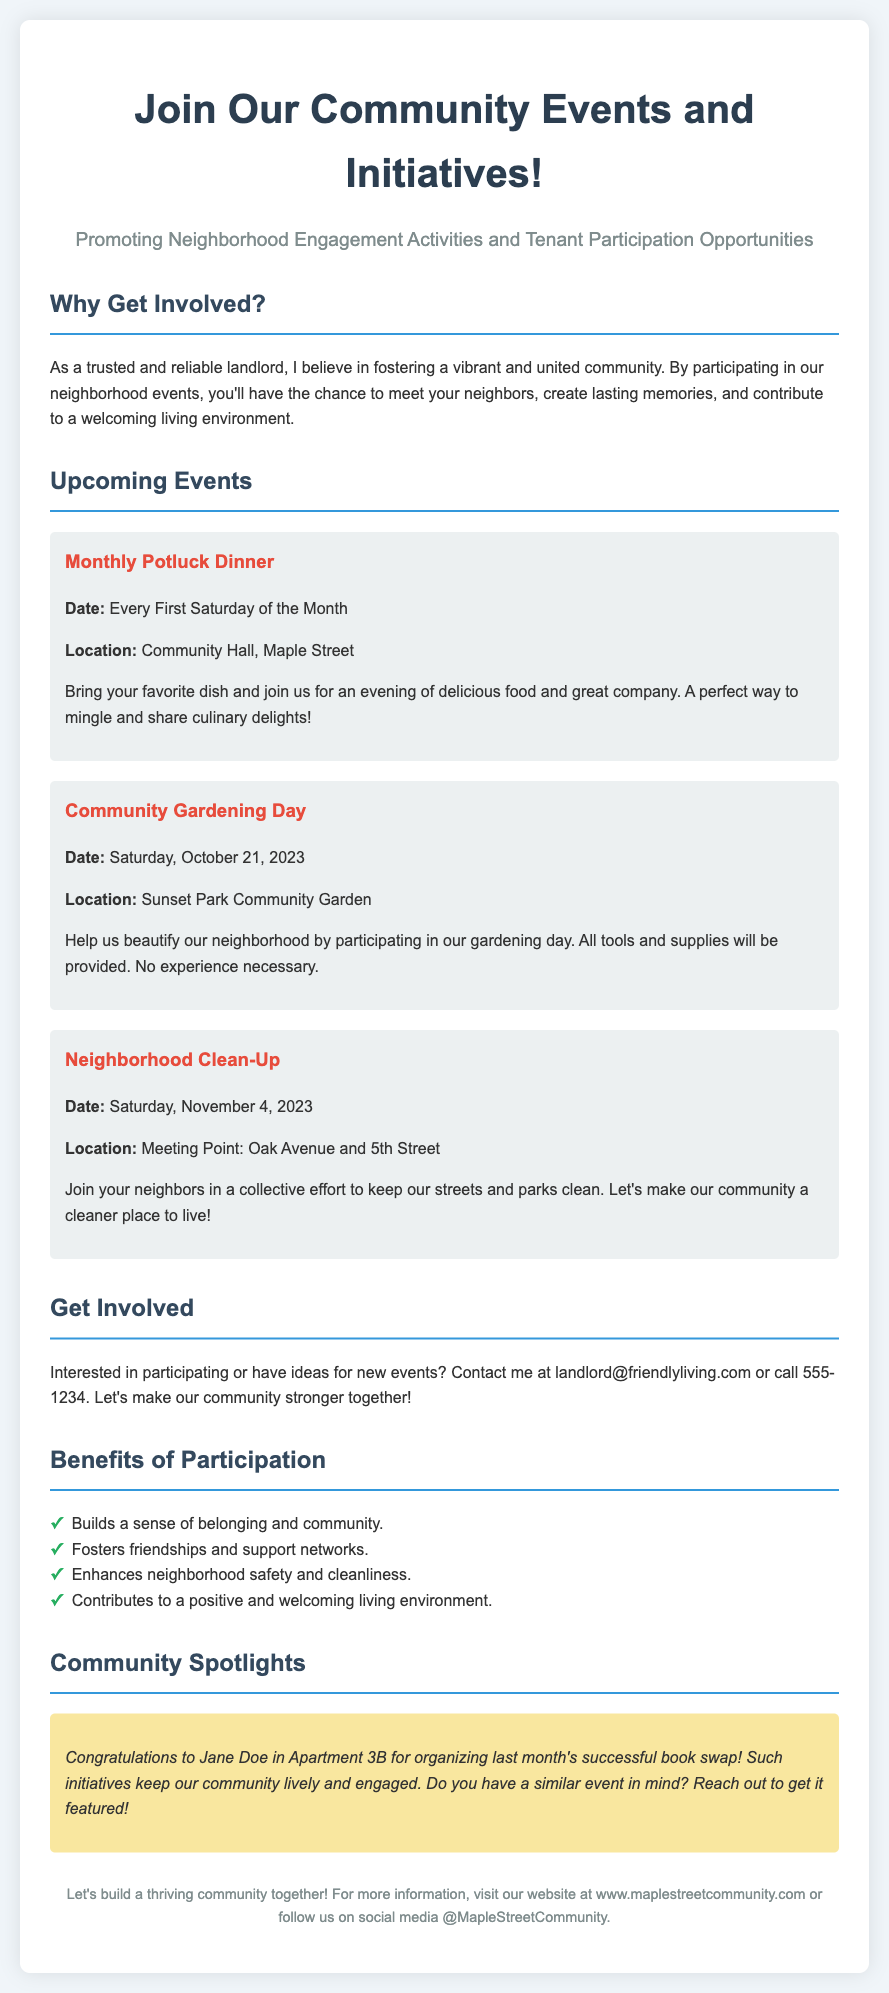What is the title of the flyer? The title is prominently displayed at the top of the document, indicating the main focus of the content.
Answer: Join Our Community Events and Initiatives! What is the date of the Community Gardening Day? The event's date is clearly mentioned in the details of that specific event section.
Answer: Saturday, October 21, 2023 Where will the Neighborhood Clean-Up take place? The location for the Neighborhood Clean-Up is noted in the event description, giving participants a clear meeting point.
Answer: Meeting Point: Oak Avenue and 5th Street What is one benefit of participating in community events? This information is summarized in a list, highlighting the advantages of community engagement.
Answer: Builds a sense of belonging and community Who organized last month's successful book swap? The document features a spotlight section highlighting a community member’s contributions, thus answering the question directly.
Answer: Jane Doe in Apartment 3B What day of the month is the Monthly Potluck Dinner held? The regular occurrence of this event is specifically described in the event details.
Answer: Every First Saturday of the Month How can residents suggest new events? The document provides contact information for residents wanting to engage further or propose events, indicating accessibility for suggestions.
Answer: Contact me at landlord@friendlyliving.com or call 555-1234 What type of event is scheduled for November 4, 2023? The nature of the event is specified in the upcoming events section, summarizing the focus of that day’s activities.
Answer: Neighborhood Clean-Up 